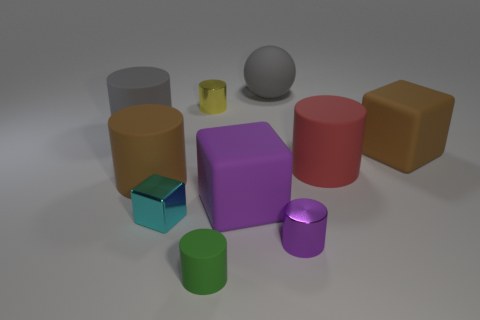Subtract all green cylinders. How many cylinders are left? 5 Subtract all large cubes. How many cubes are left? 1 Subtract all brown cylinders. Subtract all blue cubes. How many cylinders are left? 5 Subtract all balls. How many objects are left? 9 Add 4 tiny yellow metal things. How many tiny yellow metal things exist? 5 Subtract 0 blue balls. How many objects are left? 10 Subtract all purple matte cubes. Subtract all small cyan matte cylinders. How many objects are left? 9 Add 1 tiny rubber things. How many tiny rubber things are left? 2 